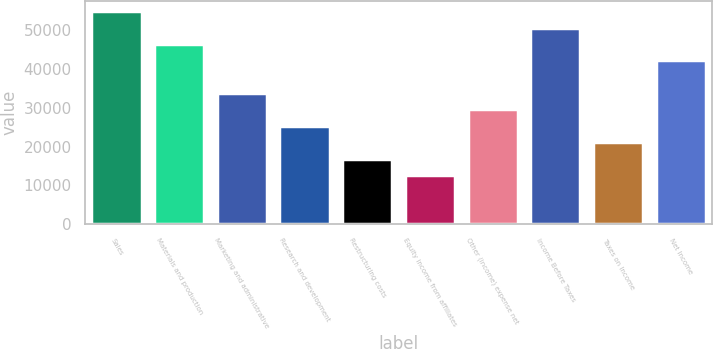<chart> <loc_0><loc_0><loc_500><loc_500><bar_chart><fcel>Sales<fcel>Materials and production<fcel>Marketing and administrative<fcel>Research and development<fcel>Restructuring costs<fcel>Equity income from affiliates<fcel>Other (income) expense net<fcel>Income Before Taxes<fcel>Taxes on Income<fcel>Net Income<nl><fcel>54906.8<fcel>46460.3<fcel>33790.4<fcel>25343.8<fcel>16897.2<fcel>12673.9<fcel>29567.1<fcel>50683.6<fcel>21120.5<fcel>42237<nl></chart> 